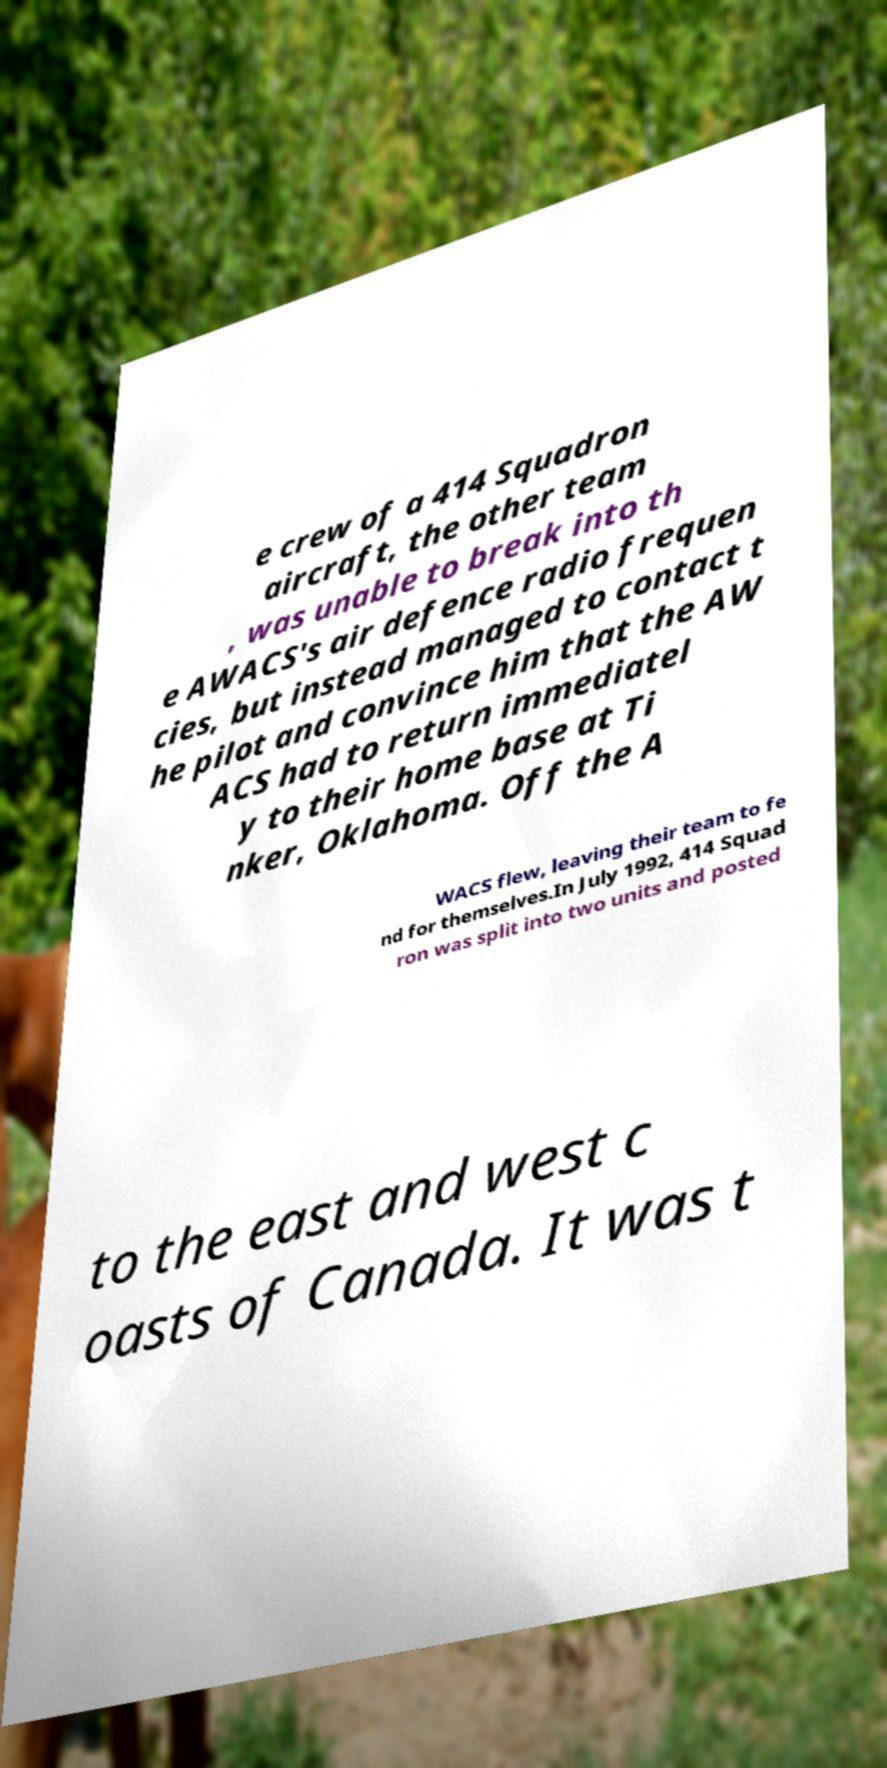Can you read and provide the text displayed in the image?This photo seems to have some interesting text. Can you extract and type it out for me? e crew of a 414 Squadron aircraft, the other team , was unable to break into th e AWACS's air defence radio frequen cies, but instead managed to contact t he pilot and convince him that the AW ACS had to return immediatel y to their home base at Ti nker, Oklahoma. Off the A WACS flew, leaving their team to fe nd for themselves.In July 1992, 414 Squad ron was split into two units and posted to the east and west c oasts of Canada. It was t 